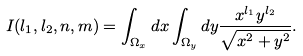<formula> <loc_0><loc_0><loc_500><loc_500>I ( l _ { 1 } , l _ { 2 } , n , m ) = \int _ { \Omega _ { x } } d x \int _ { \Omega _ { y } } d y \frac { x ^ { l _ { 1 } } y ^ { l _ { 2 } } } { \sqrt { x ^ { 2 } + y ^ { 2 } } } .</formula> 